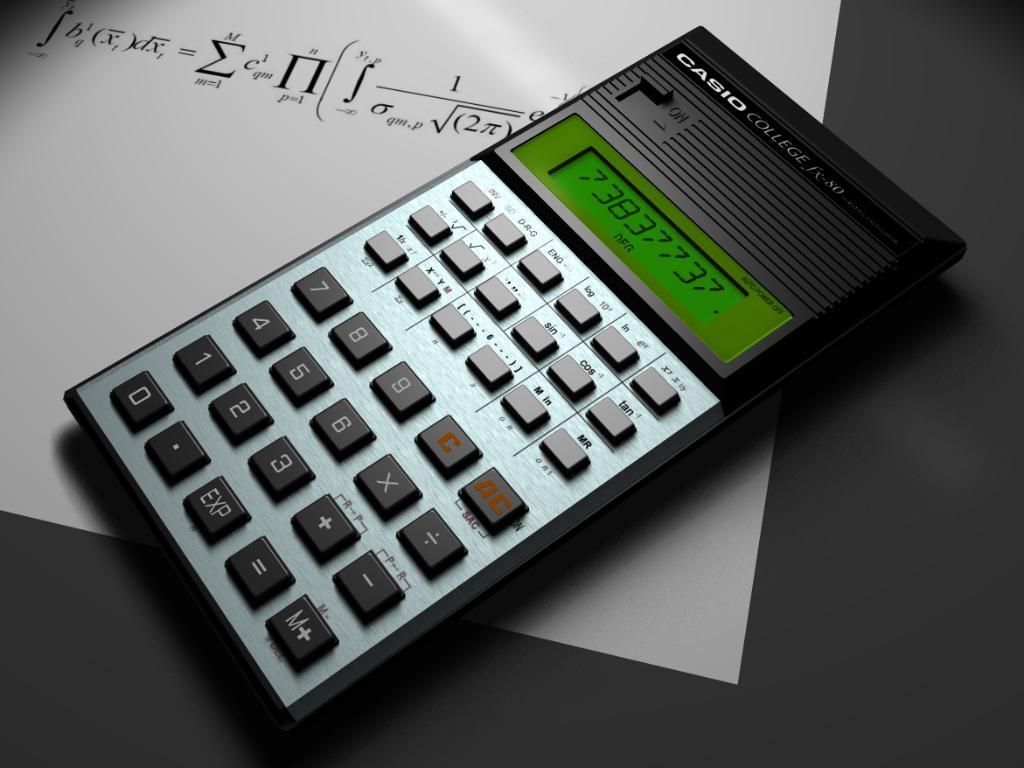Could you give a brief overview of what you see in this image? There is a calculator which is having a display and is on the white color paper on which, there is a formula. And this paper on the black color table. 